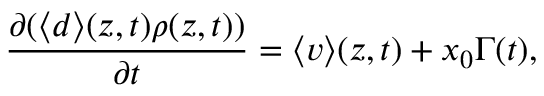<formula> <loc_0><loc_0><loc_500><loc_500>\frac { \partial ( \langle d \rangle ( z , t ) \rho ( z , t ) ) } { \partial t } = \langle v \rangle ( z , t ) + x _ { 0 } \Gamma ( t ) ,</formula> 